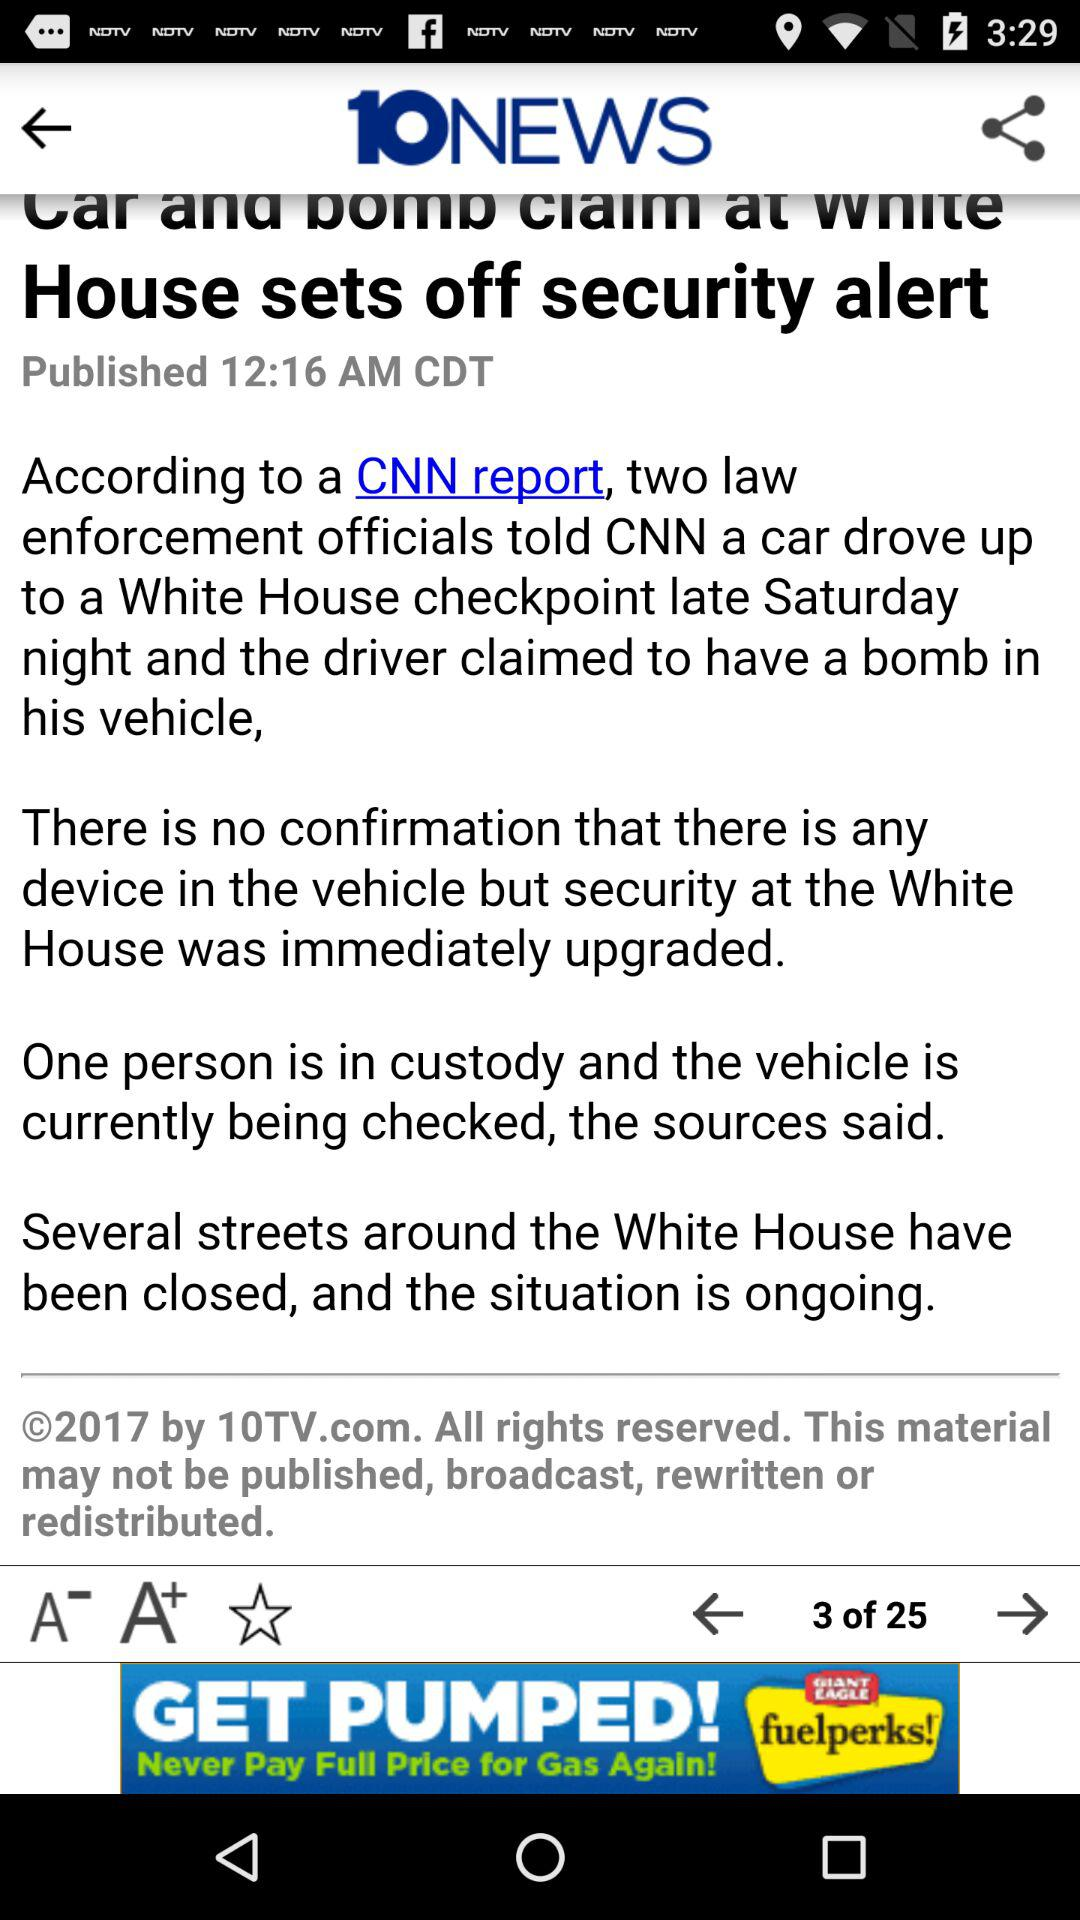What is the name of the news channel? The news channel is "10NEWS". 